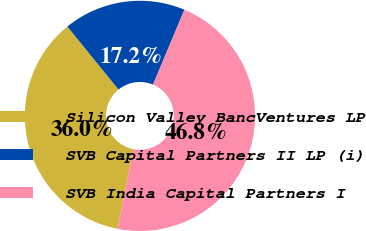Convert chart. <chart><loc_0><loc_0><loc_500><loc_500><pie_chart><fcel>Silicon Valley BancVentures LP<fcel>SVB Capital Partners II LP (i)<fcel>SVB India Capital Partners I<nl><fcel>36.03%<fcel>17.17%<fcel>46.8%<nl></chart> 